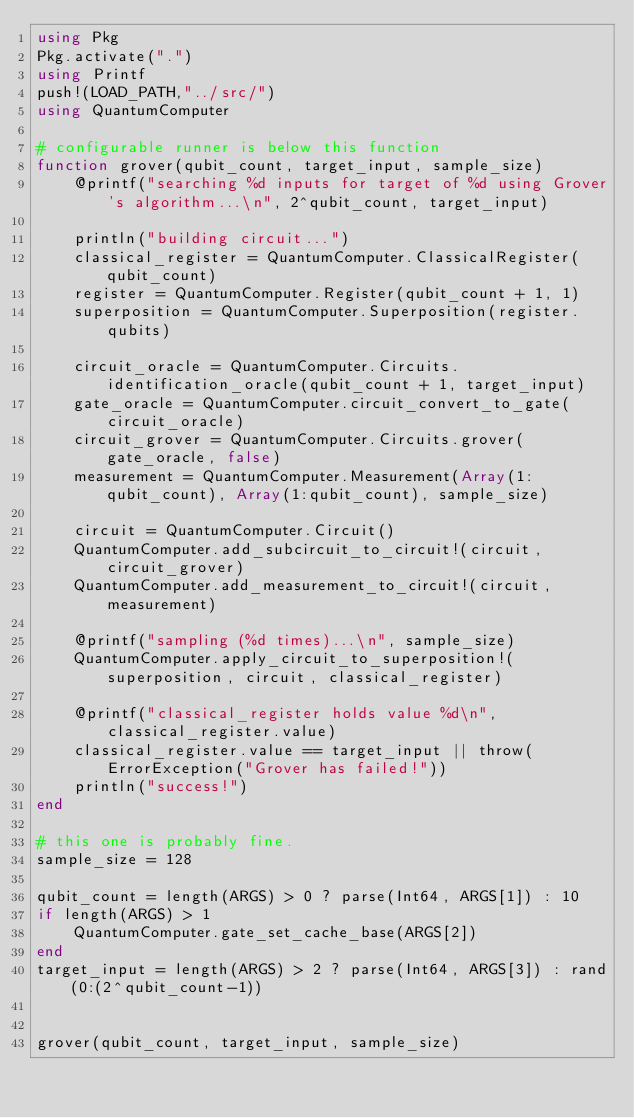<code> <loc_0><loc_0><loc_500><loc_500><_Julia_>using Pkg
Pkg.activate(".")
using Printf
push!(LOAD_PATH,"../src/")
using QuantumComputer

# configurable runner is below this function
function grover(qubit_count, target_input, sample_size)
    @printf("searching %d inputs for target of %d using Grover's algorithm...\n", 2^qubit_count, target_input)

    println("building circuit...")
    classical_register = QuantumComputer.ClassicalRegister(qubit_count)
    register = QuantumComputer.Register(qubit_count + 1, 1)
    superposition = QuantumComputer.Superposition(register.qubits)

    circuit_oracle = QuantumComputer.Circuits.identification_oracle(qubit_count + 1, target_input)
    gate_oracle = QuantumComputer.circuit_convert_to_gate(circuit_oracle)
    circuit_grover = QuantumComputer.Circuits.grover(gate_oracle, false)
    measurement = QuantumComputer.Measurement(Array(1:qubit_count), Array(1:qubit_count), sample_size)

    circuit = QuantumComputer.Circuit()
    QuantumComputer.add_subcircuit_to_circuit!(circuit, circuit_grover)
    QuantumComputer.add_measurement_to_circuit!(circuit, measurement)

    @printf("sampling (%d times)...\n", sample_size)
    QuantumComputer.apply_circuit_to_superposition!(superposition, circuit, classical_register)

    @printf("classical_register holds value %d\n", classical_register.value)
    classical_register.value == target_input || throw(ErrorException("Grover has failed!"))
    println("success!")
end

# this one is probably fine.
sample_size = 128

qubit_count = length(ARGS) > 0 ? parse(Int64, ARGS[1]) : 10
if length(ARGS) > 1
    QuantumComputer.gate_set_cache_base(ARGS[2])
end
target_input = length(ARGS) > 2 ? parse(Int64, ARGS[3]) : rand(0:(2^qubit_count-1))


grover(qubit_count, target_input, sample_size)
</code> 